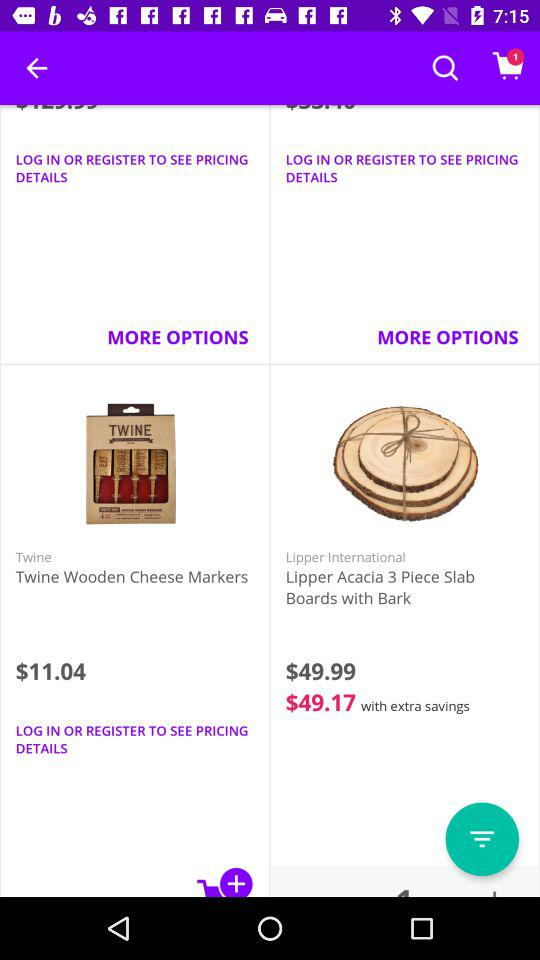How many items are in the cart? There is 1 item in the cart. 